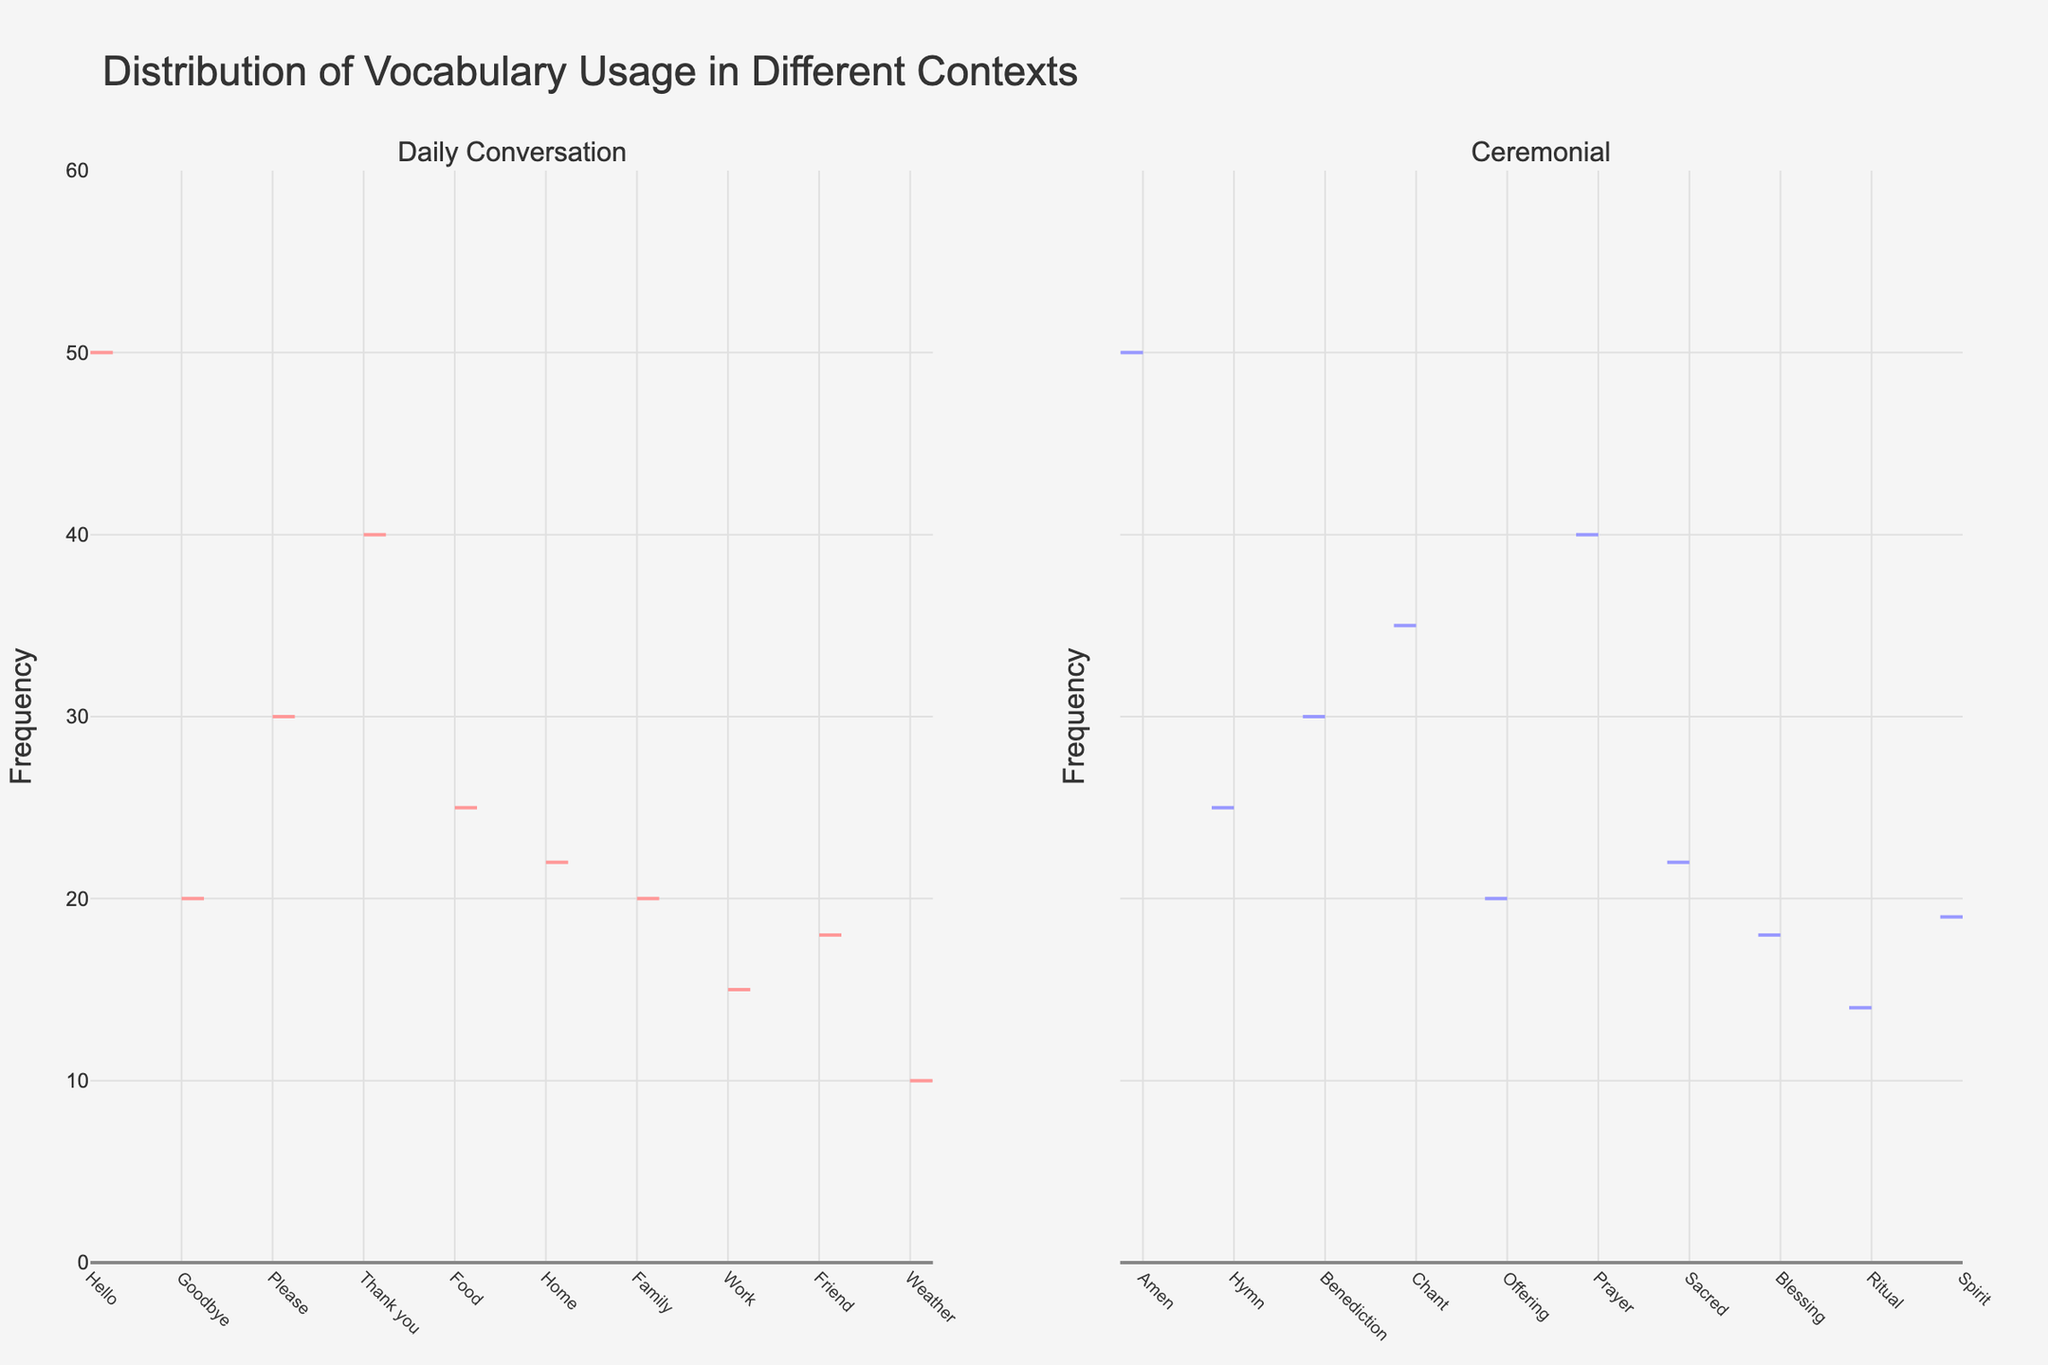What is the title of the figure? The title is usually located at the top of the figure and is formatted in a larger or bolder font.
Answer: Distribution of Vocabulary Usage in Different Contexts What is the frequency range depicted on the y-axis? The y-axis range is displayed alongside the axis, usually on the left of the figure.
Answer: 0 to 60 Which word has the highest frequency in daily conversation? In the daily conversation section of the plot, the highest frequency is visually identifiable as the tallest violin plot section.
Answer: Hello What is the frequency of the word 'Prayer' in ceremonial context? Find the 'Prayer' label in the x-axis of the ceremonial context and check the height of the violin plot segment corresponding to this word.
Answer: 40 How does the usage frequency of 'Thank you' in daily conversation compare to 'Hymn' in ceremonial context? Examine the heights of the violin plots for 'Thank you' in the daily conversation section and 'Hymn' in the ceremonial section to compare their frequencies.
Answer: Thank you: 40, Hymn: 25 What is the average frequency of the words in the daily conversation context? Add the frequencies of all words in daily conversation and divide by the number of words: (50+20+30+40+25+22+20+15+18+10) / 10
Answer: 25 What is the combined frequency of 'Blessing' and 'Ritual' in ceremonial context? Add the frequencies of 'Blessing' and 'Ritual' in the ceremonial context: 18 + 14
Answer: 32 Which context has the more uniformly distributed word frequencies, daily conversation or ceremonial? Visually inspect the spread and distribution of the violin plots in both contexts. Uniformly distributed plots will appear less variable in height.
Answer: Ceremonial Is 'Offering' used more frequently in ceremonial context compared to 'Family' in daily conversation? Compare the heights of the violin plots for 'Offering' in ceremonial context and 'Family' in daily conversation.
Answer: No What is the median frequency of the words in the ceremonial context? Arrange the frequencies in the ceremonial context in ascending order and find the middle value: (14,18,19,20,22,25,30,35,40,50)
Answer: 22.5 